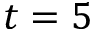<formula> <loc_0><loc_0><loc_500><loc_500>t = 5</formula> 